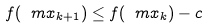<formula> <loc_0><loc_0><loc_500><loc_500>f ( \ m { x } _ { k + 1 } ) \leq f ( \ m { x } _ { k } ) - c</formula> 